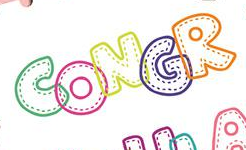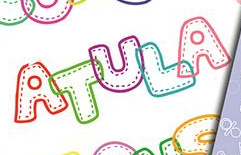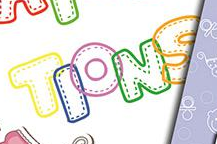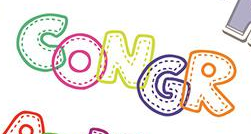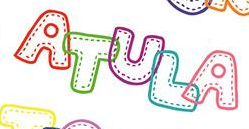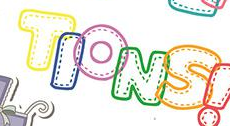What text appears in these images from left to right, separated by a semicolon? CONGR; ATULA; TIONS; CONGR; ATULA; TIONS 